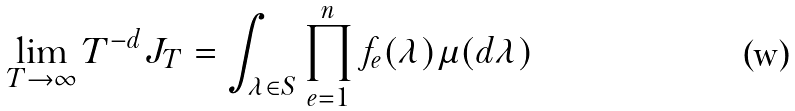<formula> <loc_0><loc_0><loc_500><loc_500>\lim _ { T \rightarrow \infty } T ^ { - d } J _ { T } = \int _ { \lambda \in S } \prod _ { e = 1 } ^ { n } f _ { e } ( \lambda ) \mu ( d \lambda )</formula> 